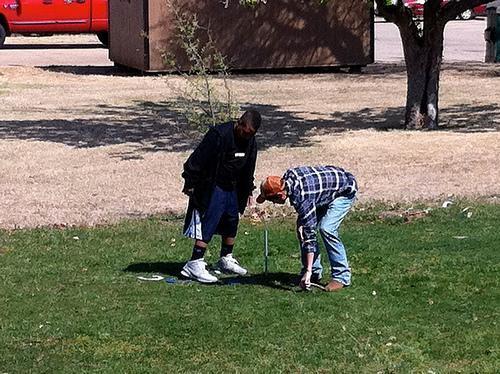How many trees are in this picture?
Give a very brief answer. 2. How many people are wearing jeans?
Give a very brief answer. 1. 